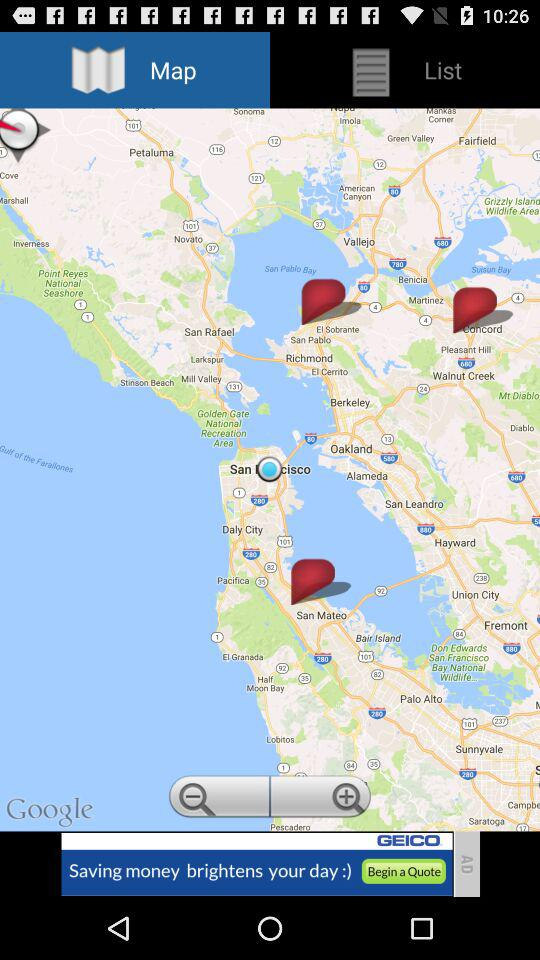What is the selected tab? The selected tab is "Map". 